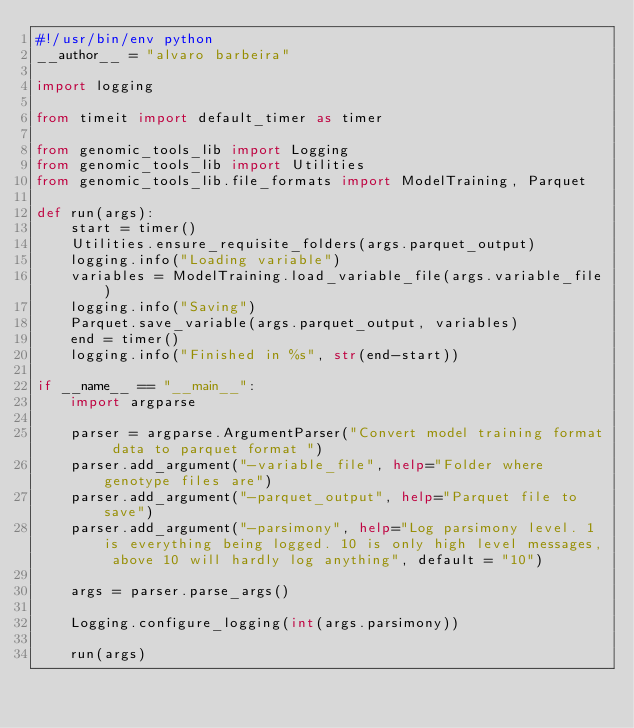Convert code to text. <code><loc_0><loc_0><loc_500><loc_500><_Python_>#!/usr/bin/env python
__author__ = "alvaro barbeira"

import logging

from timeit import default_timer as timer

from genomic_tools_lib import Logging
from genomic_tools_lib import Utilities
from genomic_tools_lib.file_formats import ModelTraining, Parquet

def run(args):
    start = timer()
    Utilities.ensure_requisite_folders(args.parquet_output)
    logging.info("Loading variable")
    variables = ModelTraining.load_variable_file(args.variable_file)
    logging.info("Saving")
    Parquet.save_variable(args.parquet_output, variables)
    end = timer()
    logging.info("Finished in %s", str(end-start))

if __name__ == "__main__":
    import argparse

    parser = argparse.ArgumentParser("Convert model training format data to parquet format ")
    parser.add_argument("-variable_file", help="Folder where genotype files are")
    parser.add_argument("-parquet_output", help="Parquet file to save")
    parser.add_argument("-parsimony", help="Log parsimony level. 1 is everything being logged. 10 is only high level messages, above 10 will hardly log anything", default = "10")

    args = parser.parse_args()

    Logging.configure_logging(int(args.parsimony))

    run(args)</code> 